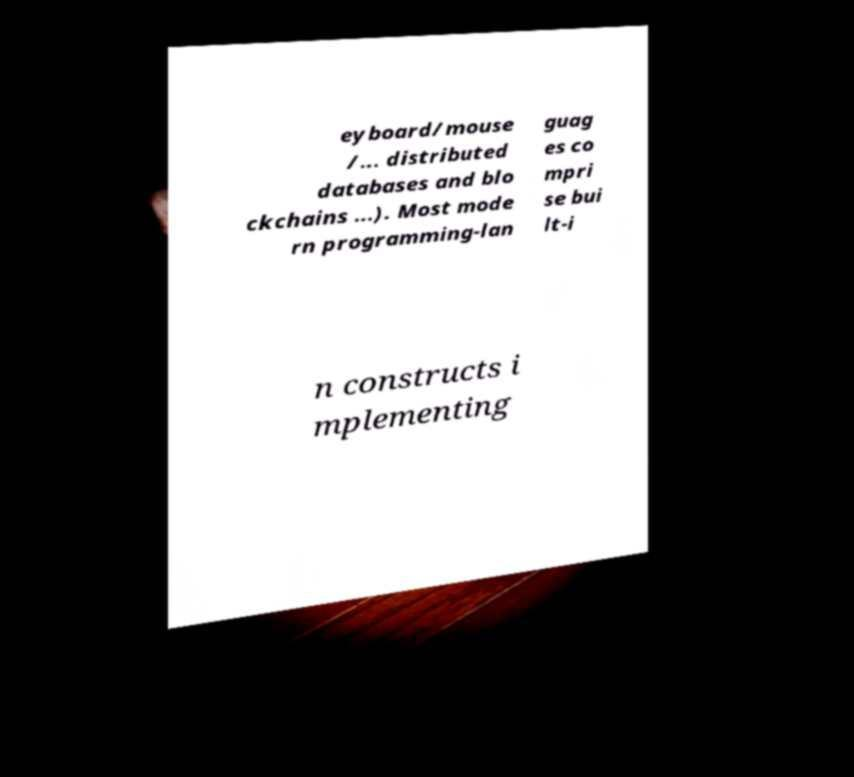I need the written content from this picture converted into text. Can you do that? eyboard/mouse /... distributed databases and blo ckchains ...). Most mode rn programming-lan guag es co mpri se bui lt-i n constructs i mplementing 